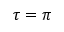Convert formula to latex. <formula><loc_0><loc_0><loc_500><loc_500>\tau = \pi</formula> 